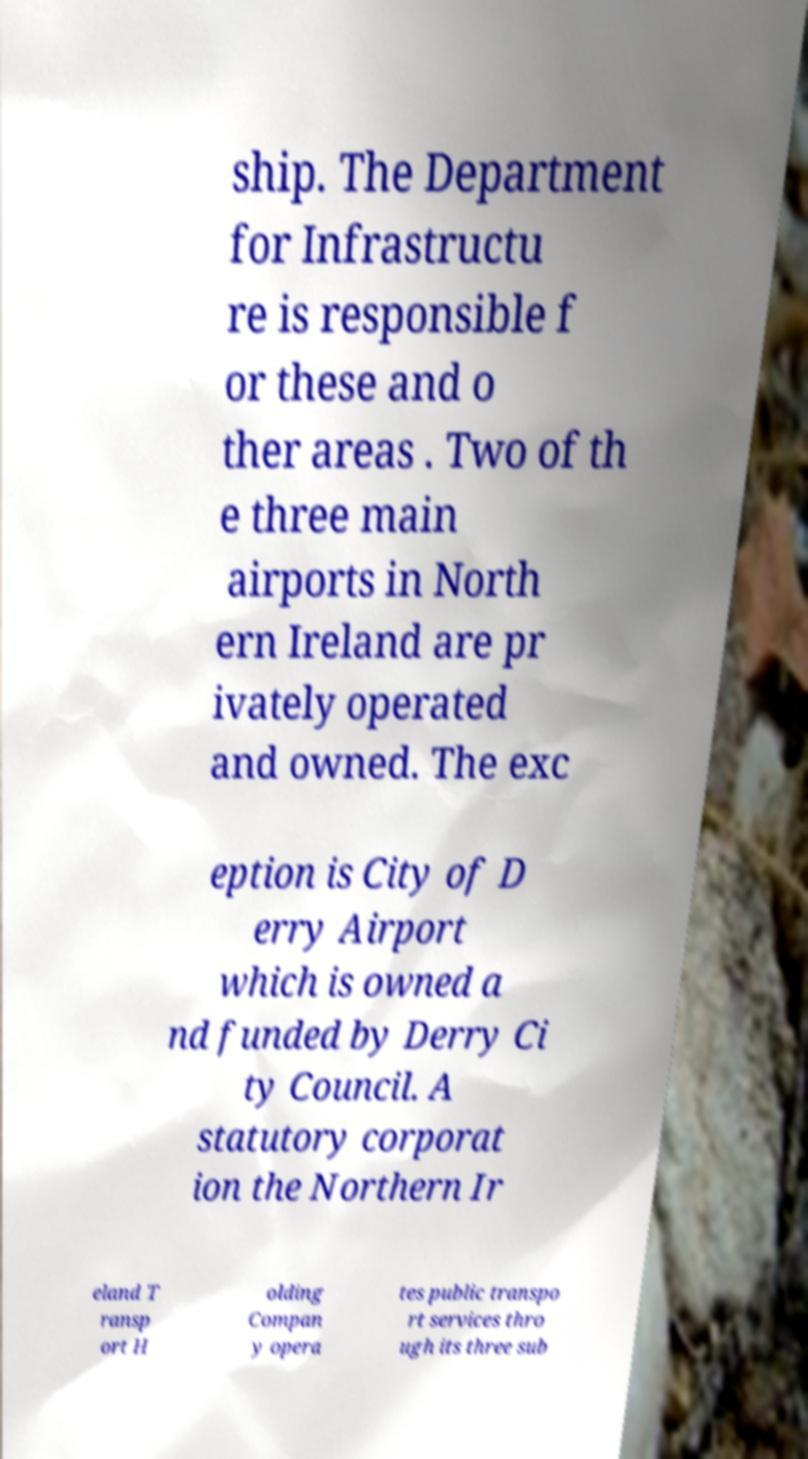For documentation purposes, I need the text within this image transcribed. Could you provide that? ship. The Department for Infrastructu re is responsible f or these and o ther areas . Two of th e three main airports in North ern Ireland are pr ivately operated and owned. The exc eption is City of D erry Airport which is owned a nd funded by Derry Ci ty Council. A statutory corporat ion the Northern Ir eland T ransp ort H olding Compan y opera tes public transpo rt services thro ugh its three sub 